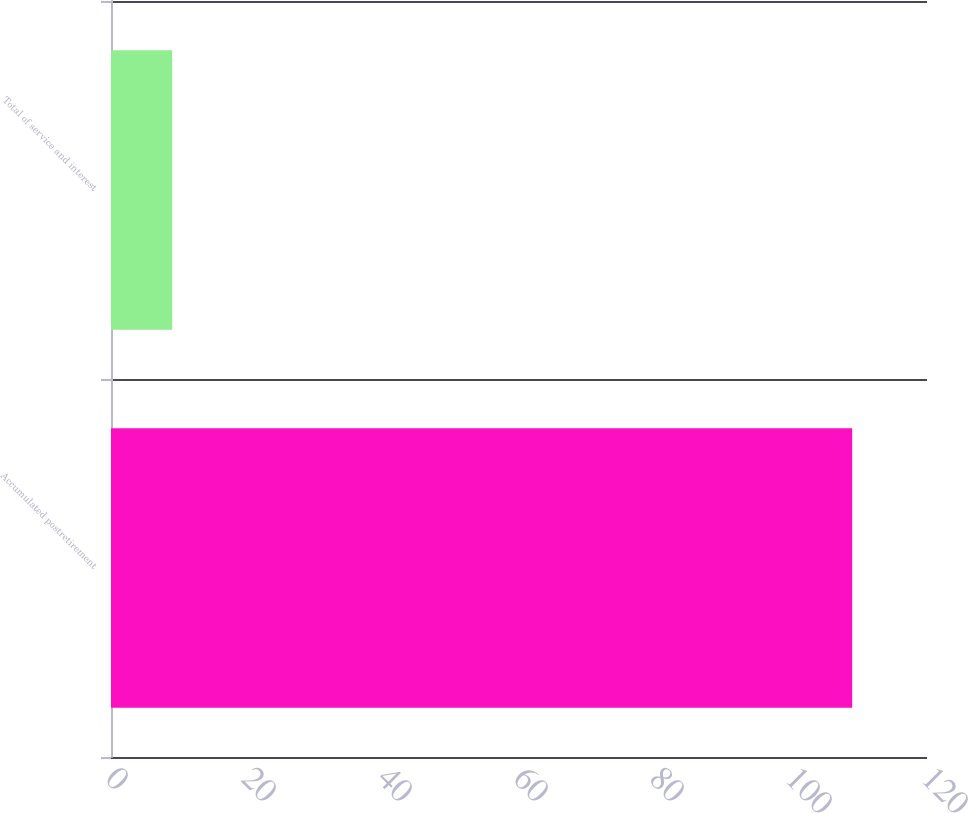<chart> <loc_0><loc_0><loc_500><loc_500><bar_chart><fcel>Accumulated postretirement<fcel>Total of service and interest<nl><fcel>109<fcel>9<nl></chart> 